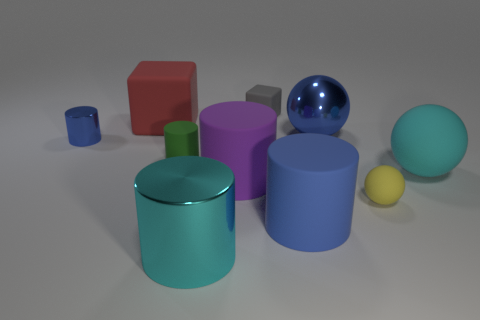What number of other things are there of the same size as the blue matte object?
Your response must be concise. 5. Are the large blue object that is behind the large purple matte object and the cyan object that is to the right of the cyan cylinder made of the same material?
Offer a terse response. No. The gray matte thing is what shape?
Provide a short and direct response. Cube. Are there the same number of small shiny cylinders that are in front of the small yellow sphere and tiny blue metal objects?
Your response must be concise. No. There is a metallic object that is the same color as the large matte sphere; what size is it?
Provide a short and direct response. Large. Is there a big cylinder made of the same material as the tiny sphere?
Your answer should be compact. Yes. Does the large cyan object that is in front of the big rubber sphere have the same shape as the blue object that is in front of the cyan ball?
Keep it short and to the point. Yes. Are any large brown metallic objects visible?
Offer a terse response. No. There is a rubber block that is the same size as the cyan metallic cylinder; what color is it?
Offer a very short reply. Red. How many other small gray things are the same shape as the gray object?
Offer a terse response. 0. 